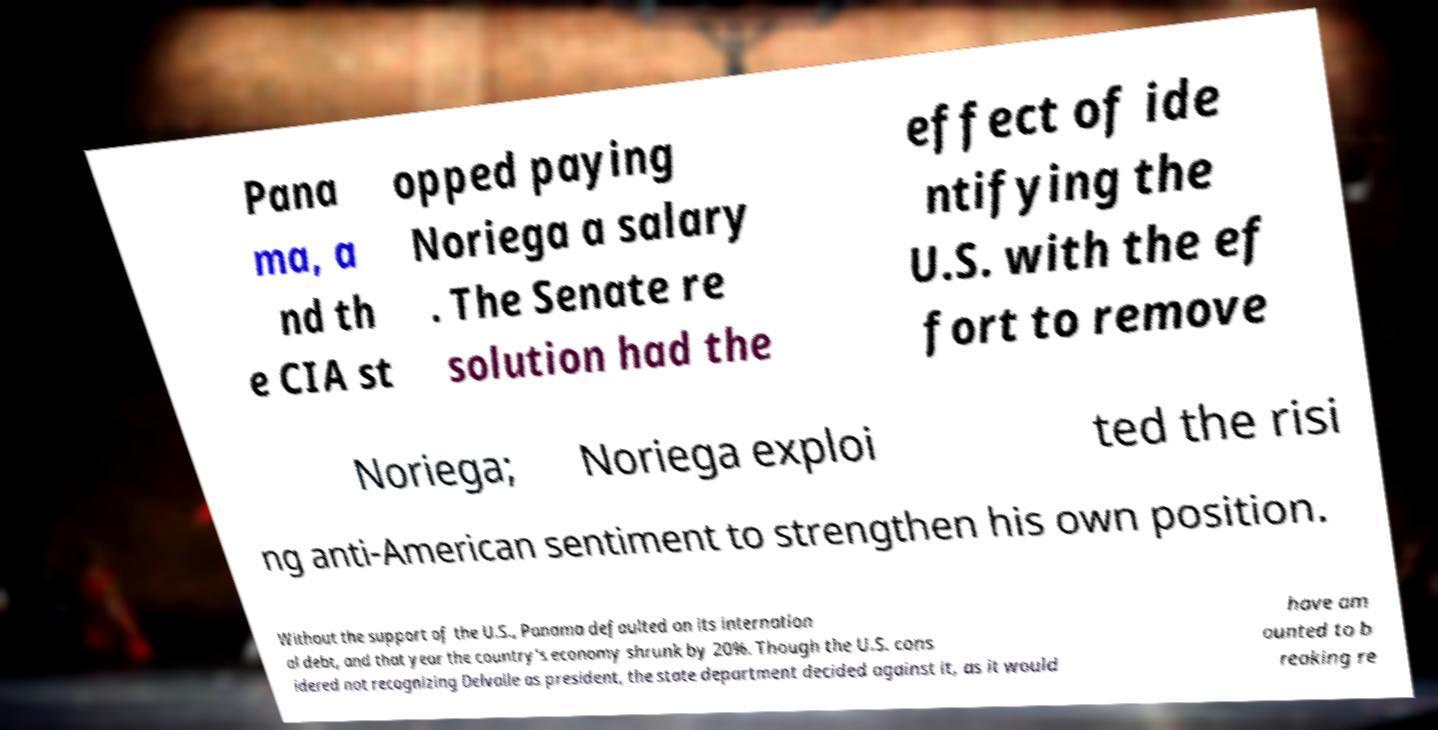Can you read and provide the text displayed in the image?This photo seems to have some interesting text. Can you extract and type it out for me? Pana ma, a nd th e CIA st opped paying Noriega a salary . The Senate re solution had the effect of ide ntifying the U.S. with the ef fort to remove Noriega; Noriega exploi ted the risi ng anti-American sentiment to strengthen his own position. Without the support of the U.S., Panama defaulted on its internation al debt, and that year the country's economy shrunk by 20%. Though the U.S. cons idered not recognizing Delvalle as president, the state department decided against it, as it would have am ounted to b reaking re 